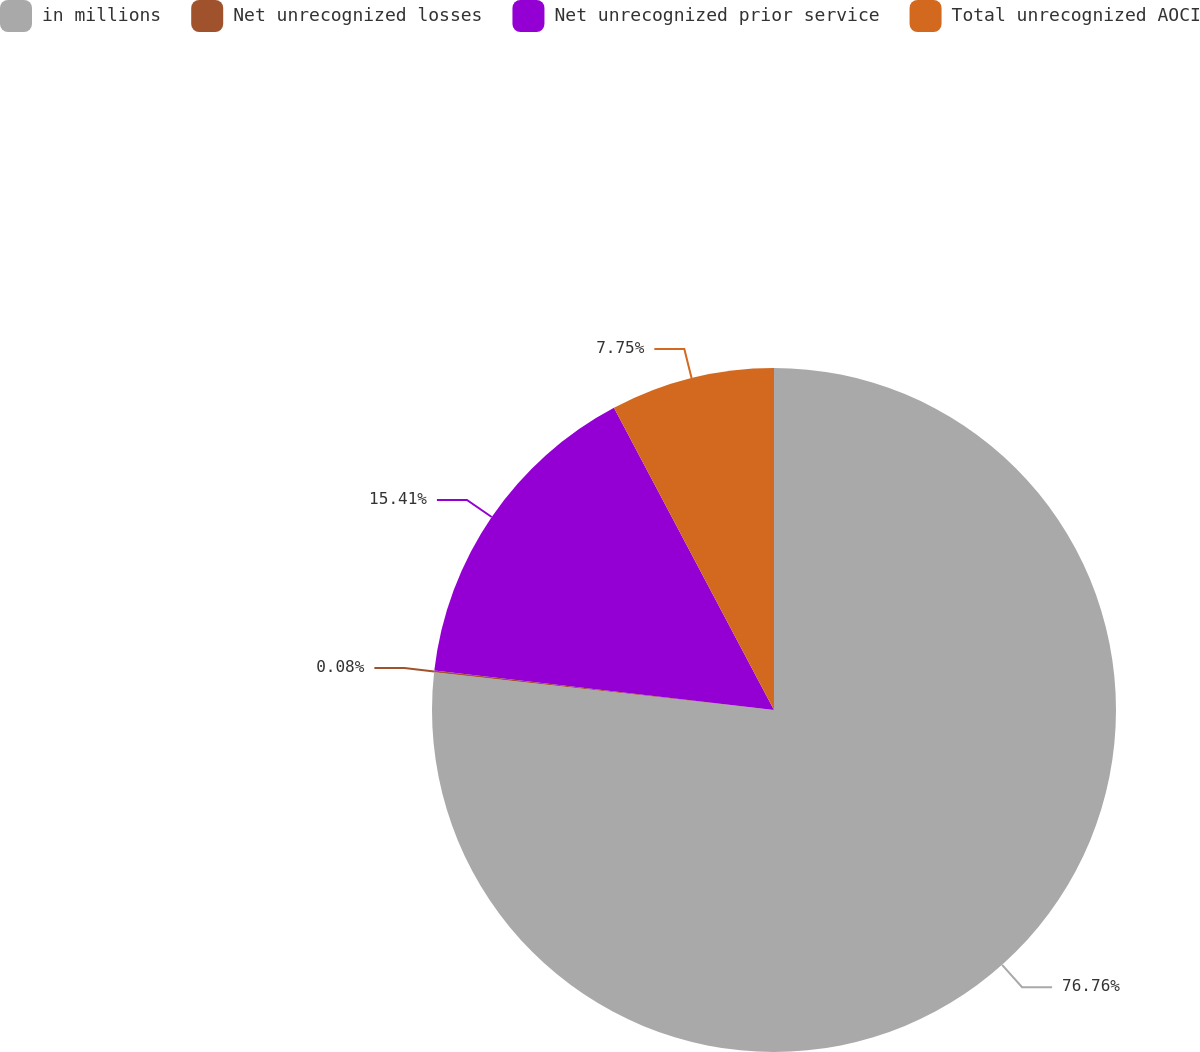Convert chart to OTSL. <chart><loc_0><loc_0><loc_500><loc_500><pie_chart><fcel>in millions<fcel>Net unrecognized losses<fcel>Net unrecognized prior service<fcel>Total unrecognized AOCI<nl><fcel>76.76%<fcel>0.08%<fcel>15.41%<fcel>7.75%<nl></chart> 